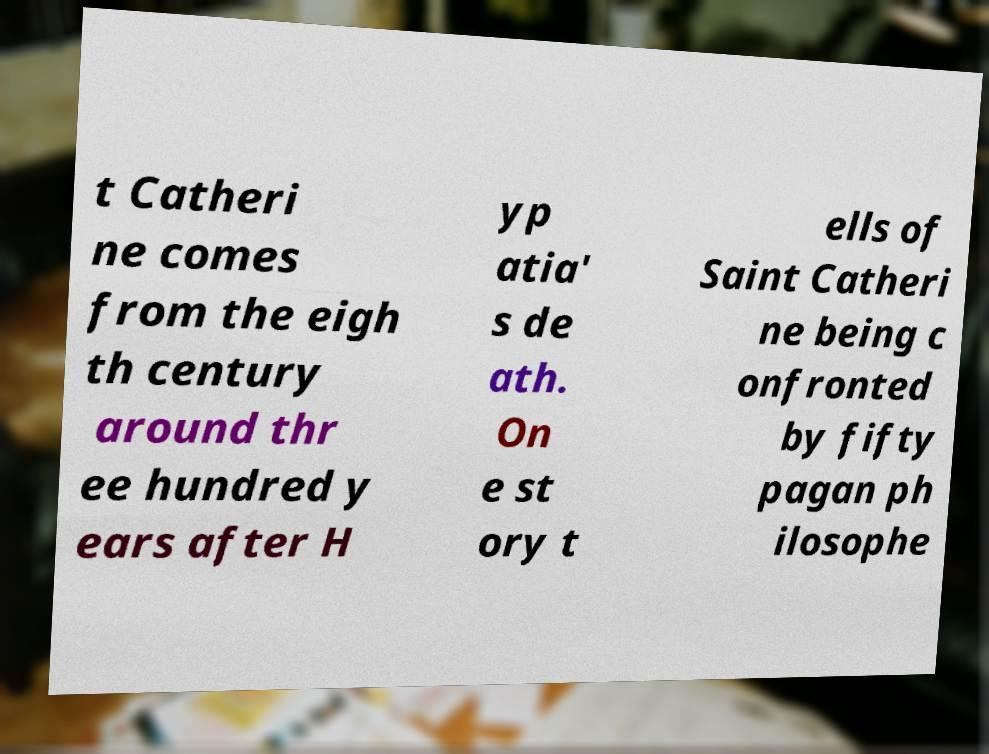Please read and relay the text visible in this image. What does it say? t Catheri ne comes from the eigh th century around thr ee hundred y ears after H yp atia' s de ath. On e st ory t ells of Saint Catheri ne being c onfronted by fifty pagan ph ilosophe 